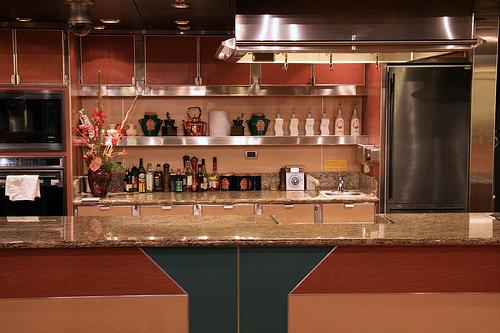Mention a unique detail about the oven in the image. The oven has a white towel hanging from its door handle. What lies on the ceiling, and what is its purpose? Recessed lighting is on the ceiling, which helps illuminate the kitchen area. In a casual and informal tone, tell me what you see in the image related to kitchen appliances. Yo! There's a stainless steel fridge, a microwave mounted on the wall, and an oven with a white towel hanging from it. What aspect of the kitchen captures the essence of the contemporary design? The stainless steel refrigerator and appliances showcase the modern aesthetics in the kitchen. Enumerate the color variations of the items on the kitchen countertop. Gold, white, brown, red, and silver. Identify the objects found on the kitchen countertop. Gold teapot, vase full of flowers, condiments, white food scale, brown pepper grinder. 